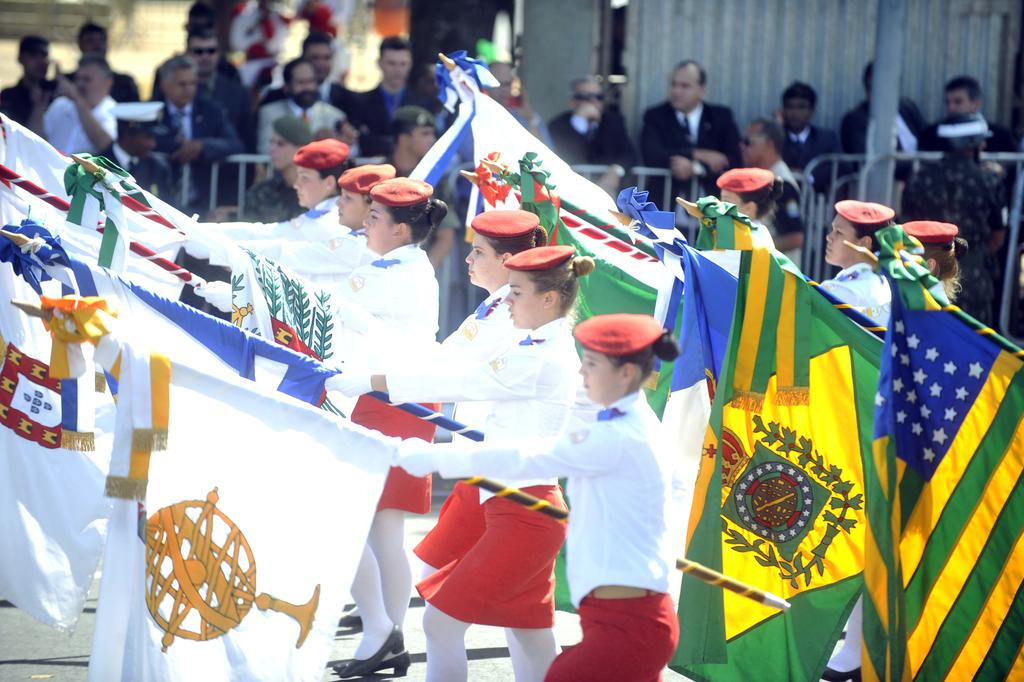What are the persons in the center of the image doing? The persons in the center of the image are walking. What are the persons holding in their hands? The persons are holding flags in their hands. What can be seen in the background of the image? There are persons standing, a fence, and a pole in the background of the image. What is causing the persons to cry in the image? There is no indication in the image that the persons are crying, and therefore no such cause can be determined. 